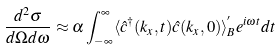Convert formula to latex. <formula><loc_0><loc_0><loc_500><loc_500>\frac { d ^ { 2 } \sigma } { d \Omega d \omega } \approx \alpha \int _ { - \infty } ^ { \infty } \langle \hat { c } ^ { \dagger } ( k _ { x } , t ) \hat { c } ( k _ { x } , 0 ) \rangle _ { B } ^ { ^ { \prime } } e ^ { i \omega t } d t</formula> 